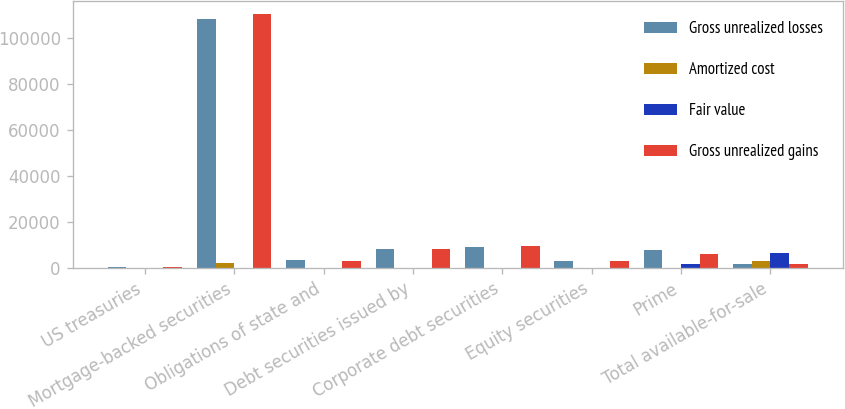Convert chart. <chart><loc_0><loc_0><loc_500><loc_500><stacked_bar_chart><ecel><fcel>US treasuries<fcel>Mortgage-backed securities<fcel>Obligations of state and<fcel>Debt securities issued by<fcel>Corporate debt securities<fcel>Equity securities<fcel>Prime<fcel>Total available-for-sale<nl><fcel>Gross unrealized losses<fcel>616<fcel>108360<fcel>3479<fcel>8173<fcel>9358<fcel>3073<fcel>7762<fcel>1998<nl><fcel>Amortized cost<fcel>2<fcel>2257<fcel>94<fcel>173<fcel>257<fcel>2<fcel>4<fcel>3264<nl><fcel>Fair value<fcel>7<fcel>214<fcel>238<fcel>2<fcel>61<fcel>7<fcel>1739<fcel>6683<nl><fcel>Gross unrealized gains<fcel>611<fcel>110403<fcel>3335<fcel>8344<fcel>9554<fcel>3068<fcel>6027<fcel>1998<nl></chart> 